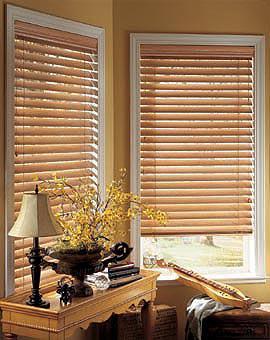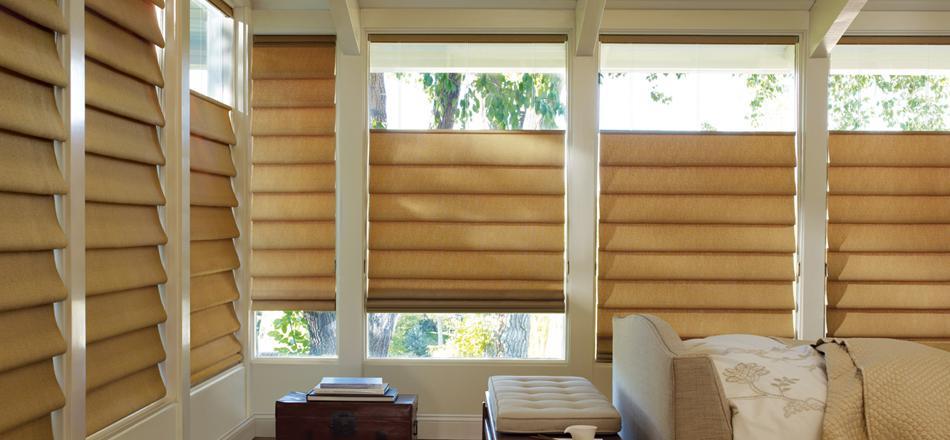The first image is the image on the left, the second image is the image on the right. Evaluate the accuracy of this statement regarding the images: "The left and right image contains a total of six blinds.". Is it true? Answer yes or no. No. The first image is the image on the left, the second image is the image on the right. Analyze the images presented: Is the assertion "there are three windows with white trim and a sofa with pillows in front of it" valid? Answer yes or no. No. 